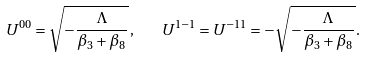Convert formula to latex. <formula><loc_0><loc_0><loc_500><loc_500>U ^ { 0 0 } = \sqrt { - \frac { \Lambda } { \beta _ { 3 } + \beta _ { 8 } } } \, , \quad U ^ { 1 - 1 } = U ^ { - 1 1 } = - \sqrt { - \frac { \Lambda } { \beta _ { 3 } + \beta _ { 8 } } } \, .</formula> 